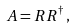<formula> <loc_0><loc_0><loc_500><loc_500>A = R R ^ { \dagger } \, ,</formula> 